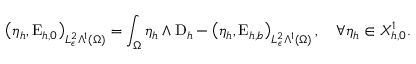Convert formula to latex. <formula><loc_0><loc_0><loc_500><loc_500>\left ( \eta _ { h } , E _ { h , 0 } \right ) _ { L _ { \epsilon } ^ { 2 } \Lambda ^ { 1 } ( \Omega ) } = \int _ { \Omega } \eta _ { h } \wedge D _ { h } - \left ( \eta _ { h } , E _ { h , b } \right ) _ { L _ { \epsilon } ^ { 2 } \Lambda ^ { 1 } ( \Omega ) } , \quad \forall \eta _ { h } \in X _ { h , 0 } ^ { 1 } .</formula> 